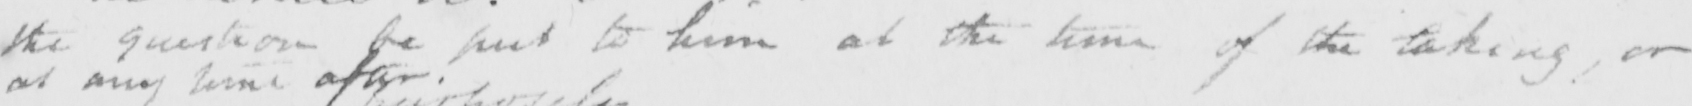What does this handwritten line say? the question be put to him at the time of the taking , or 